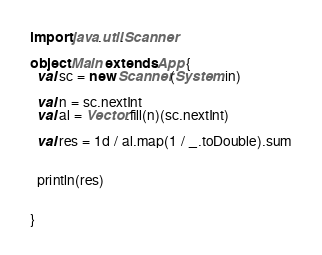<code> <loc_0><loc_0><loc_500><loc_500><_Scala_>import java.util.Scanner

object Main extends App {
  val sc = new Scanner(System.in)

  val n = sc.nextInt
  val al = Vector.fill(n)(sc.nextInt)

  val res = 1d / al.map(1 / _.toDouble).sum


  println(res)


}
</code> 